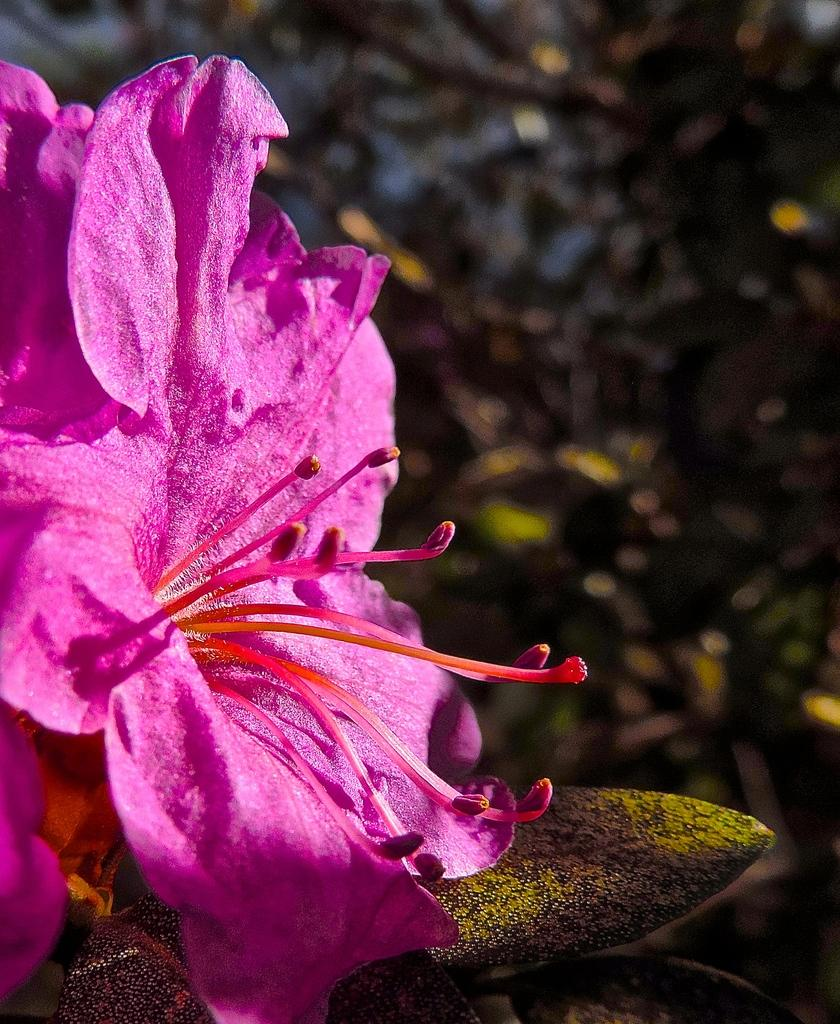What is the main subject of the image? There is a flower in the center of the image. What color is the flower? The flower is pink in color. How would you describe the background of the image? The background of the image is blurry. What type of question is being asked in the image? There is no question present in the image; it features a pink flower with a blurry background. 